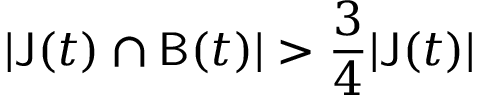Convert formula to latex. <formula><loc_0><loc_0><loc_500><loc_500>| J ( t ) \cap B ( t ) | > \frac { 3 } { 4 } | J ( t ) |</formula> 